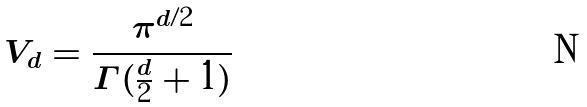<formula> <loc_0><loc_0><loc_500><loc_500>V _ { d } = \frac { \pi ^ { d / 2 } } { \Gamma ( \frac { d } { 2 } + 1 ) }</formula> 